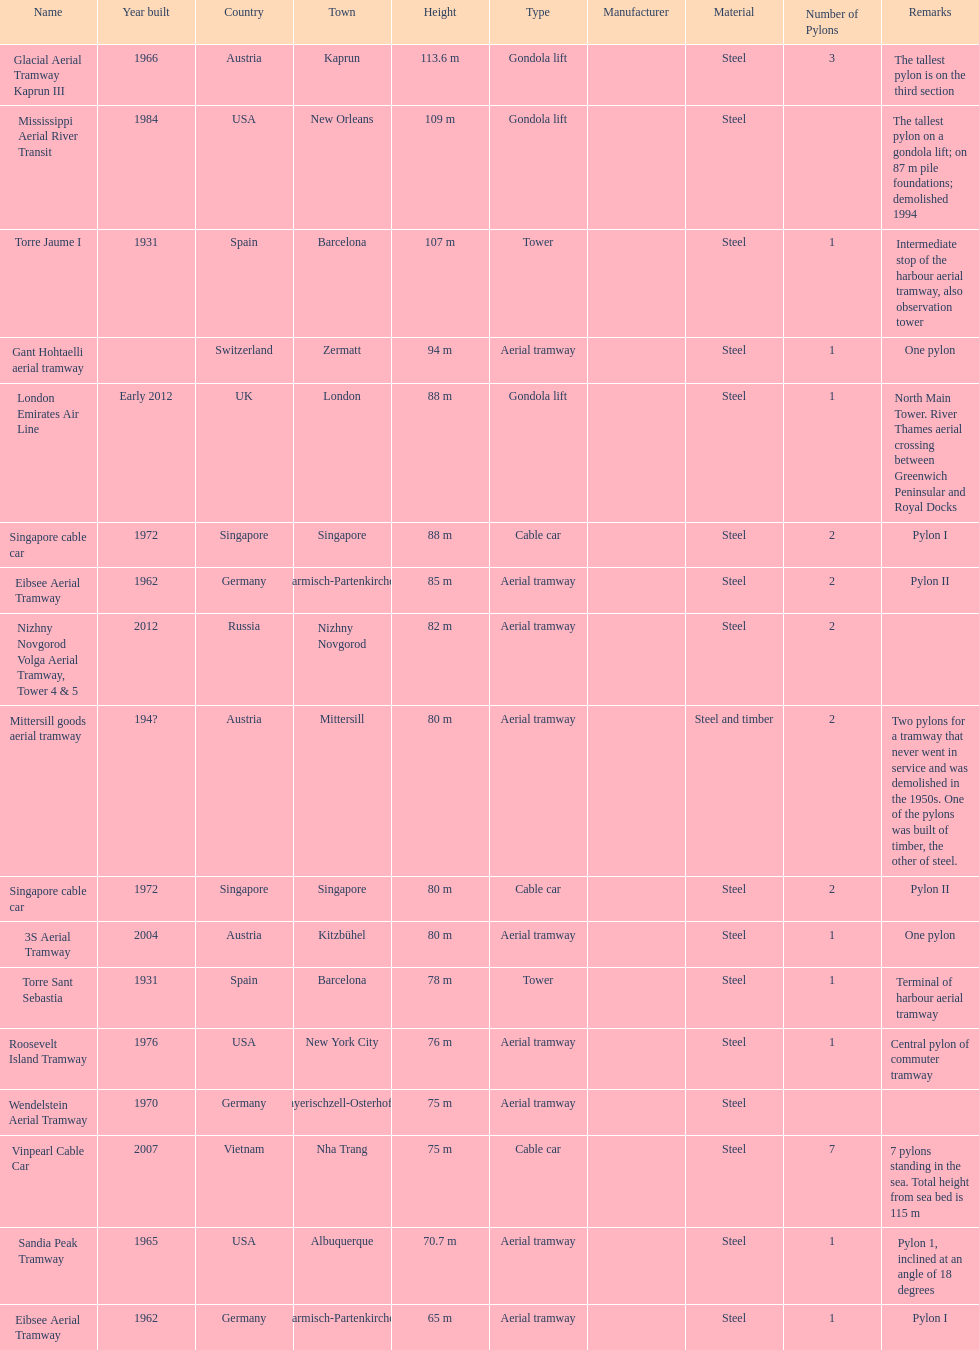How many pylons are at least 80 meters tall? 11. 